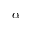Convert formula to latex. <formula><loc_0><loc_0><loc_500><loc_500>\alpha</formula> 